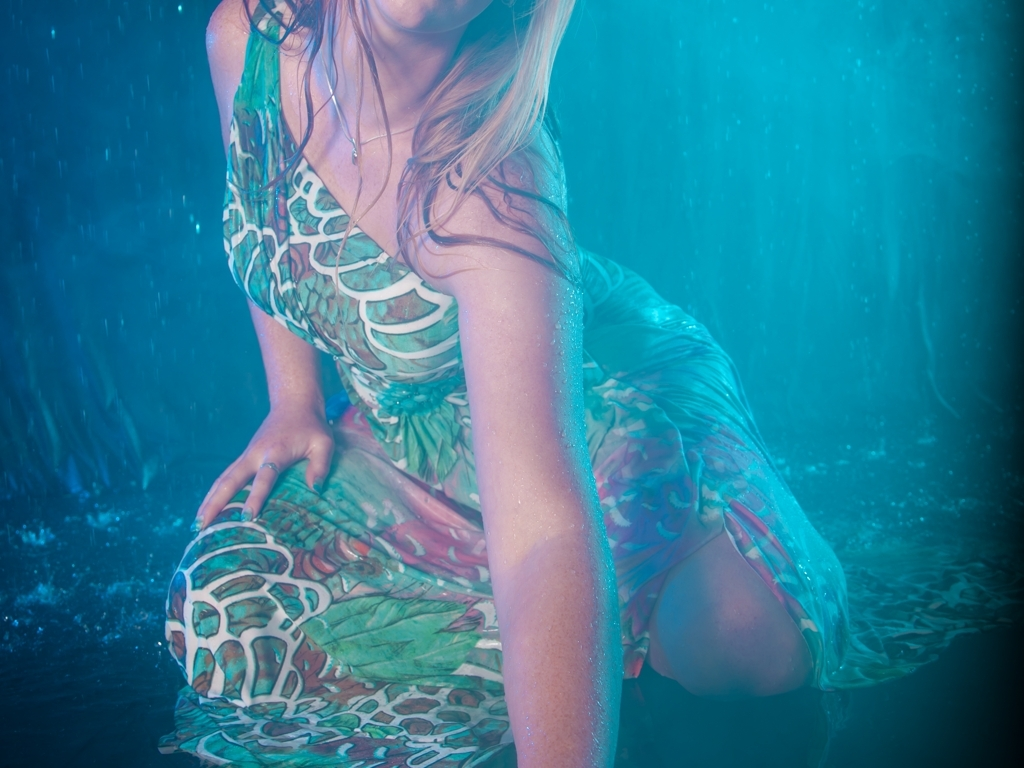How does the lighting in the photo affect the mood or atmosphere? The lighting in the photo creates an ethereal or otherworldly mood, with a vibrant blue hue that enshrouds the subject, contributing to a sense of being submerged in an aquatic environment. The highlights and contrasts accentuate the water droplets and the texture of the dress, enhancing the overall mystical quality of the scene. 